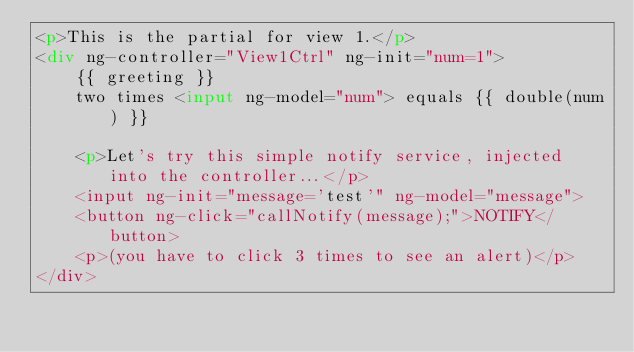Convert code to text. <code><loc_0><loc_0><loc_500><loc_500><_HTML_><p>This is the partial for view 1.</p>
<div ng-controller="View1Ctrl" ng-init="num=1">
    {{ greeting }}
    two times <input ng-model="num"> equals {{ double(num) }}

    <p>Let's try this simple notify service, injected into the controller...</p>
    <input ng-init="message='test'" ng-model="message">
    <button ng-click="callNotify(message);">NOTIFY</button>
    <p>(you have to click 3 times to see an alert)</p>
</div></code> 